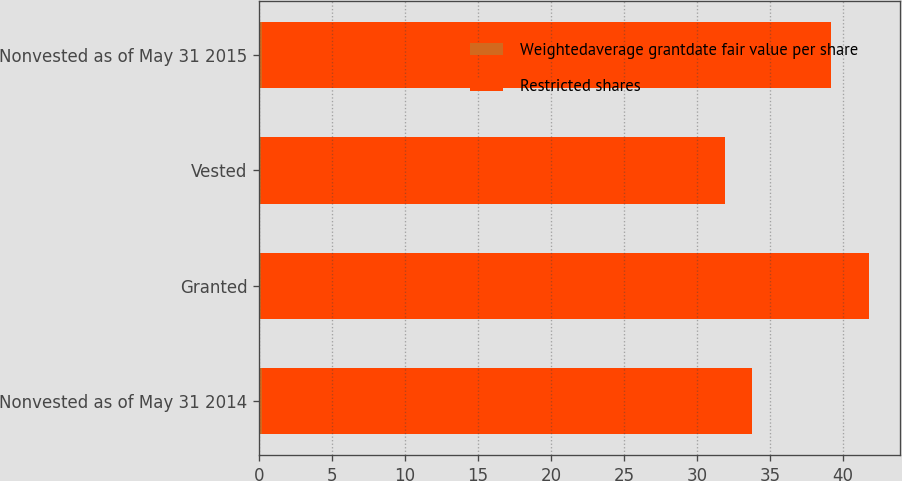Convert chart. <chart><loc_0><loc_0><loc_500><loc_500><stacked_bar_chart><ecel><fcel>Nonvested as of May 31 2014<fcel>Granted<fcel>Vested<fcel>Nonvested as of May 31 2015<nl><fcel>Weightedaverage grantdate fair value per share<fcel>0.2<fcel>0.1<fcel>0.1<fcel>0.2<nl><fcel>Restricted shares<fcel>33.55<fcel>41.7<fcel>31.79<fcel>38.99<nl></chart> 